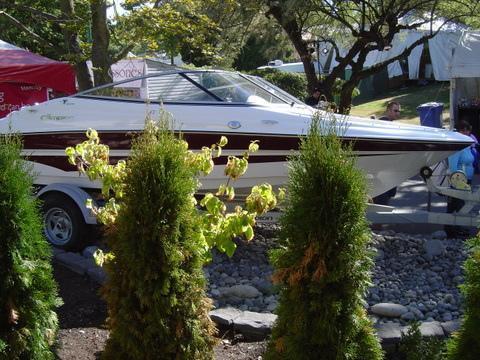What is the closest major city from this outdoor area?
Select the correct answer and articulate reasoning with the following format: 'Answer: answer
Rationale: rationale.'
Options: Portland, seattle, vancouver, edmonton. Answer: vancouver.
Rationale: This area is in canada. 